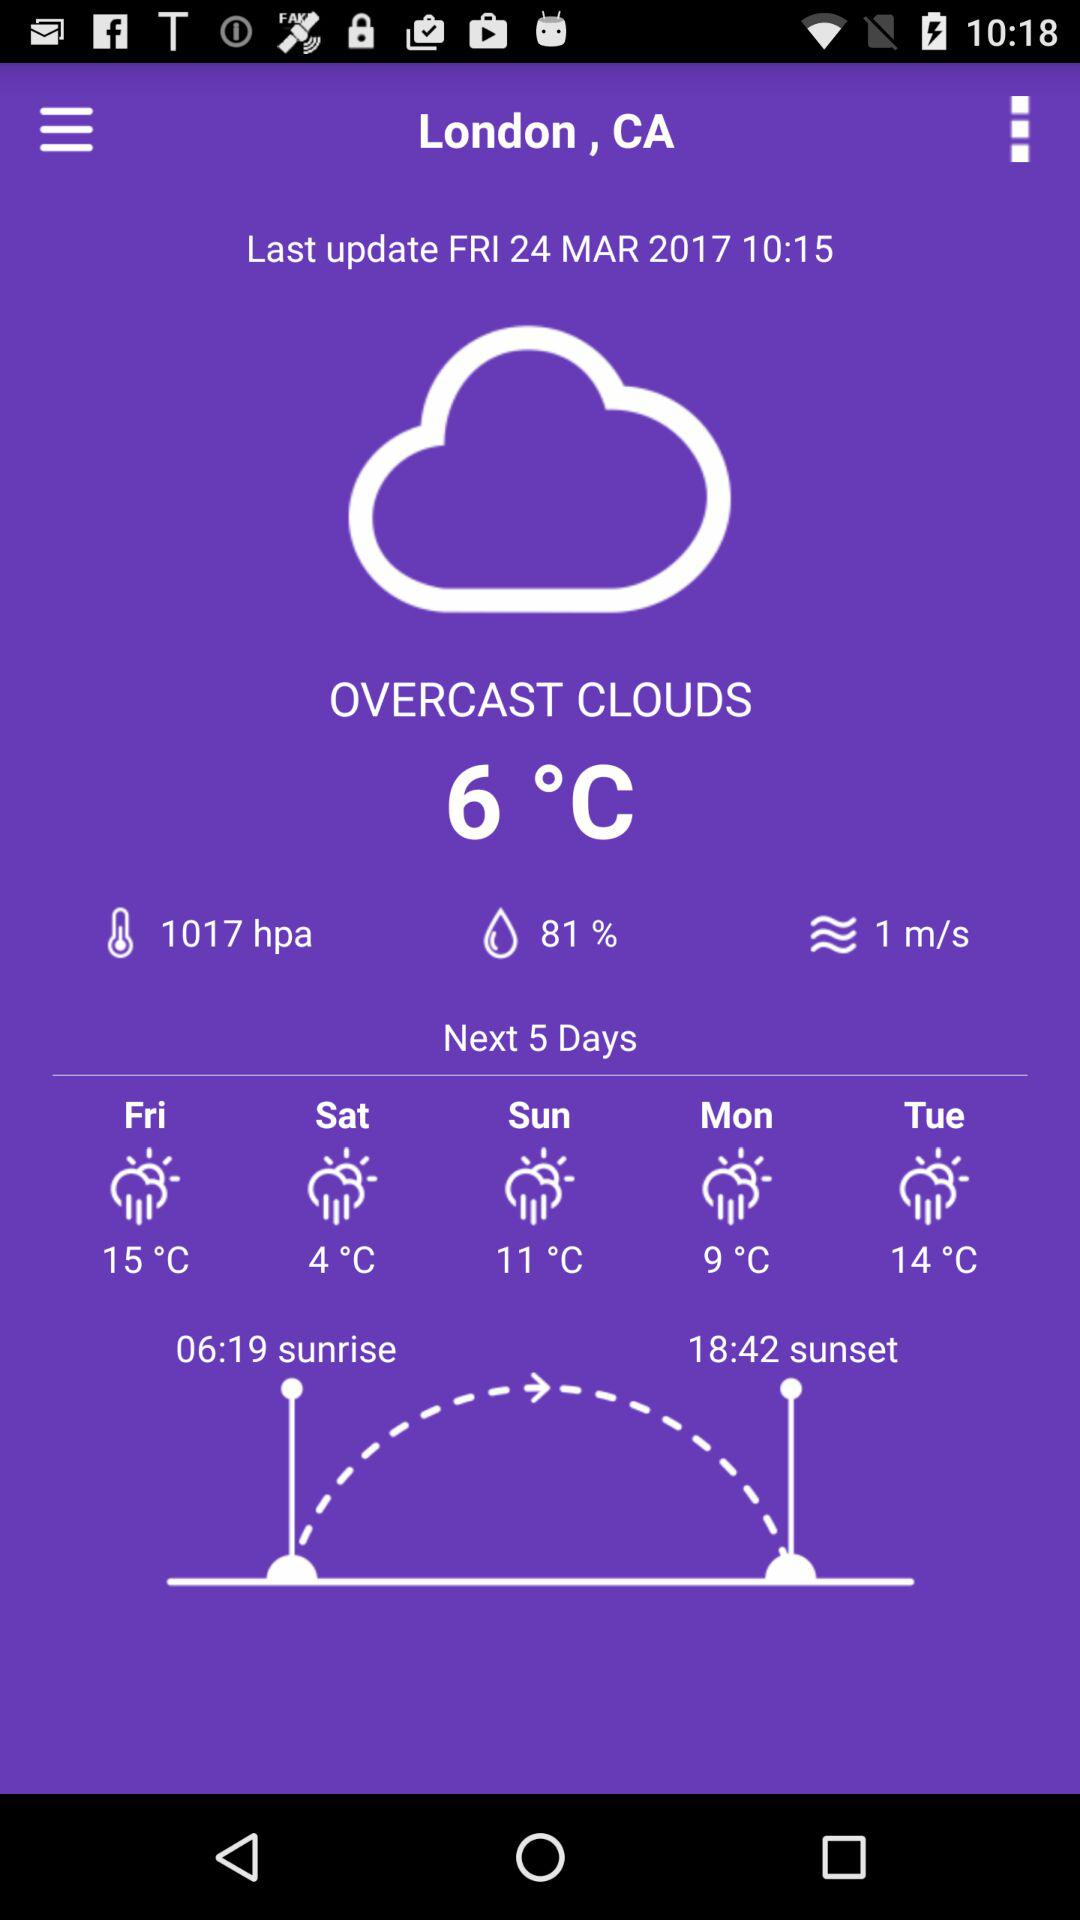What is the temperature for Friday?
Answer the question using a single word or phrase. 15°C 